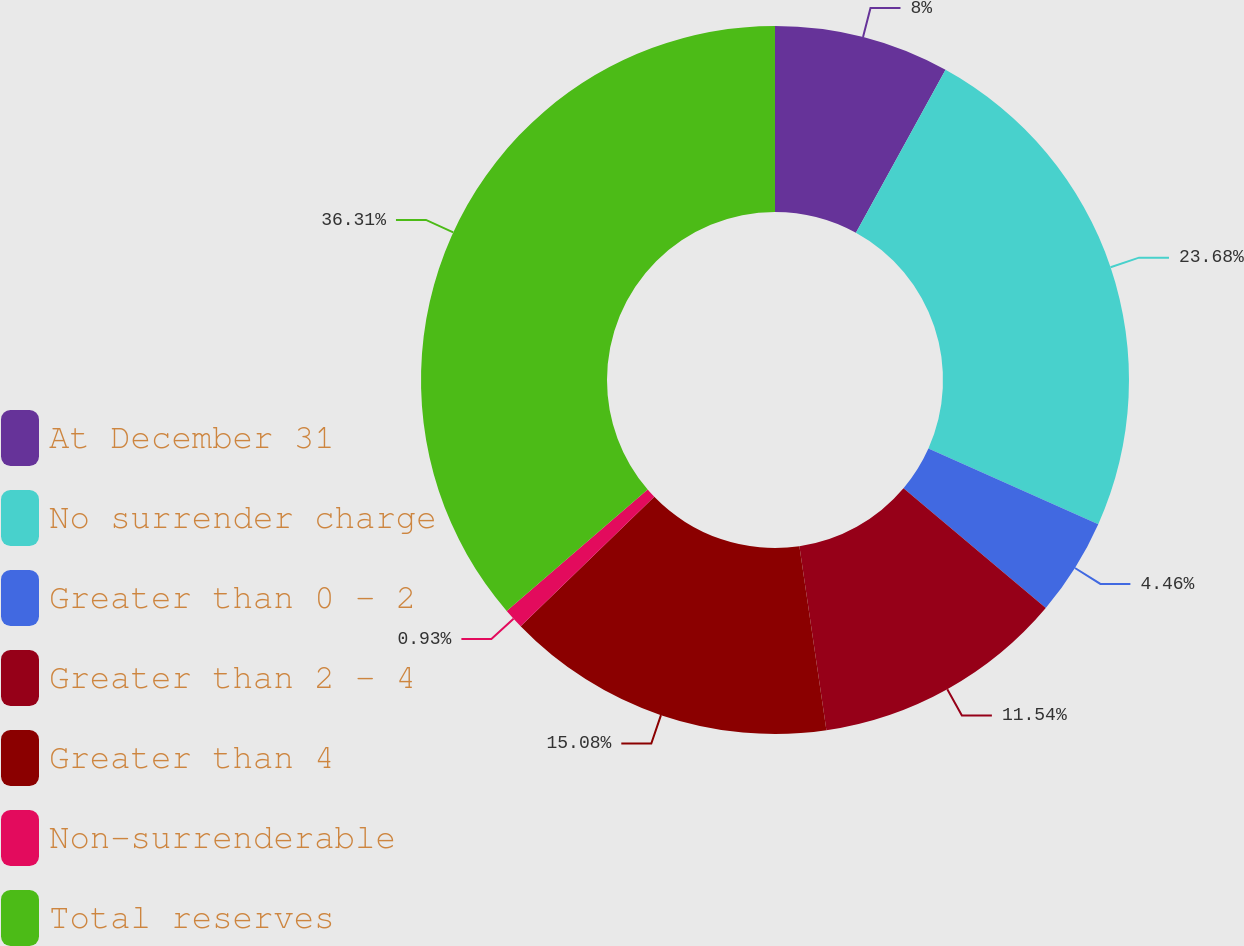Convert chart to OTSL. <chart><loc_0><loc_0><loc_500><loc_500><pie_chart><fcel>At December 31<fcel>No surrender charge<fcel>Greater than 0 - 2<fcel>Greater than 2 - 4<fcel>Greater than 4<fcel>Non-surrenderable<fcel>Total reserves<nl><fcel>8.0%<fcel>23.68%<fcel>4.46%<fcel>11.54%<fcel>15.08%<fcel>0.93%<fcel>36.31%<nl></chart> 